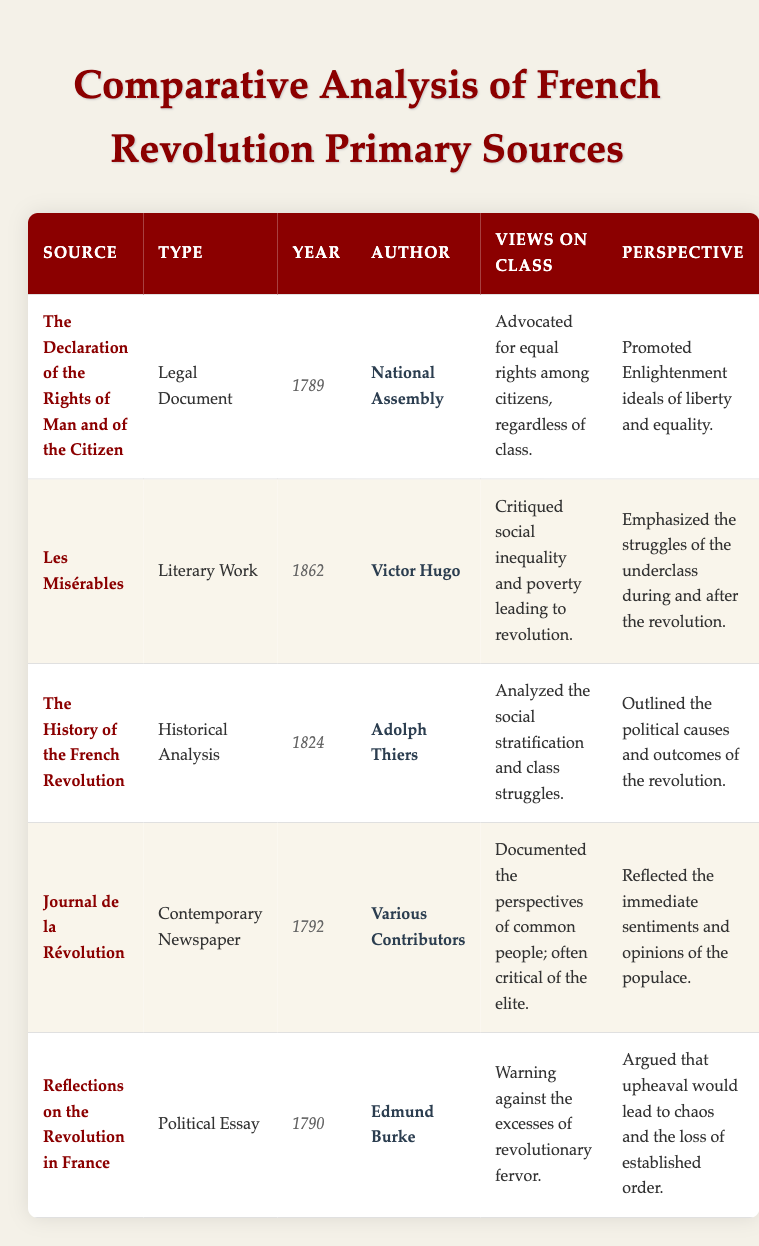What year was "Les Misérables" published? The table explicitly states that "Les Misérables" was published in the year 1862.
Answer: 1862 Who authored "The Declaration of the Rights of Man and of the Citizen"? According to the table, the author of "The Declaration of the Rights of Man and of the Citizen" is listed as the National Assembly.
Answer: National Assembly Which source critiques social inequality? The table points out that "Les Misérables" critiques social inequality and poverty leading to revolution. Since it is the only source with this specific view, the answer is clear.
Answer: Les Misérables Did Edmund Burke view the revolution positively? The table indicates that Edmund Burke warned against the excesses of revolutionary fervor, implying a negative view, therefore the answer is no.
Answer: No What type of document is "The History of the French Revolution"? The information from the table specifies that "The History of the French Revolution" is classified as a historical analysis.
Answer: Historical Analysis Which two sources were published before 1790? By reviewing the year column, "The Declaration of the Rights of Man and of the Citizen" (1789) and "Journal de la Révolution" (1792) are identified as published in this timeframe. Notably, "The History of the French Revolution” (1824) comes later than 1790.
Answer: The Declaration of the Rights of Man and of the Citizen; Journal de la Révolution Count the number of sources that reflect Enlightenment ideals. The table indicates that "The Declaration of the Rights of Man and of the Citizen" specifically promoted Enlightenment ideals of liberty and equality; hence, only one source matches this criteria.
Answer: 1 What is the main perspective presented in "Journal de la Révolution"? The table reveals that "Journal de la Révolution" reflects the immediate sentiments and opinions of the populace, thus providing a clear perspective regarding its content.
Answer: It reflects the immediate sentiments and opinions of the populace Which author analyzed social stratification and class struggles? The table notes that Adolph Thiers, author of "The History of the French Revolution," analyzed social stratification and class struggles, highlighting his analytical focus on these issues.
Answer: Adolph Thiers 